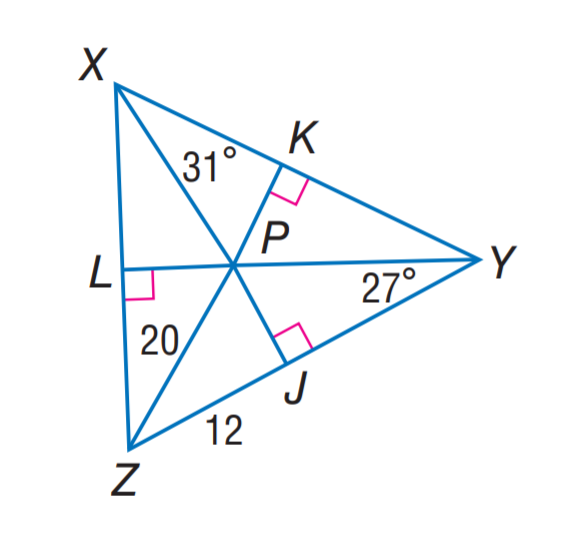Question: P is the incenter of \angle X Y Z. Find m \angle L Z P.
Choices:
A. 20
B. 27
C. 31
D. 32
Answer with the letter. Answer: D Question: P is the incenter of \angle X Y Z. Find P K.
Choices:
A. 8
B. 12
C. 16
D. 20
Answer with the letter. Answer: C 